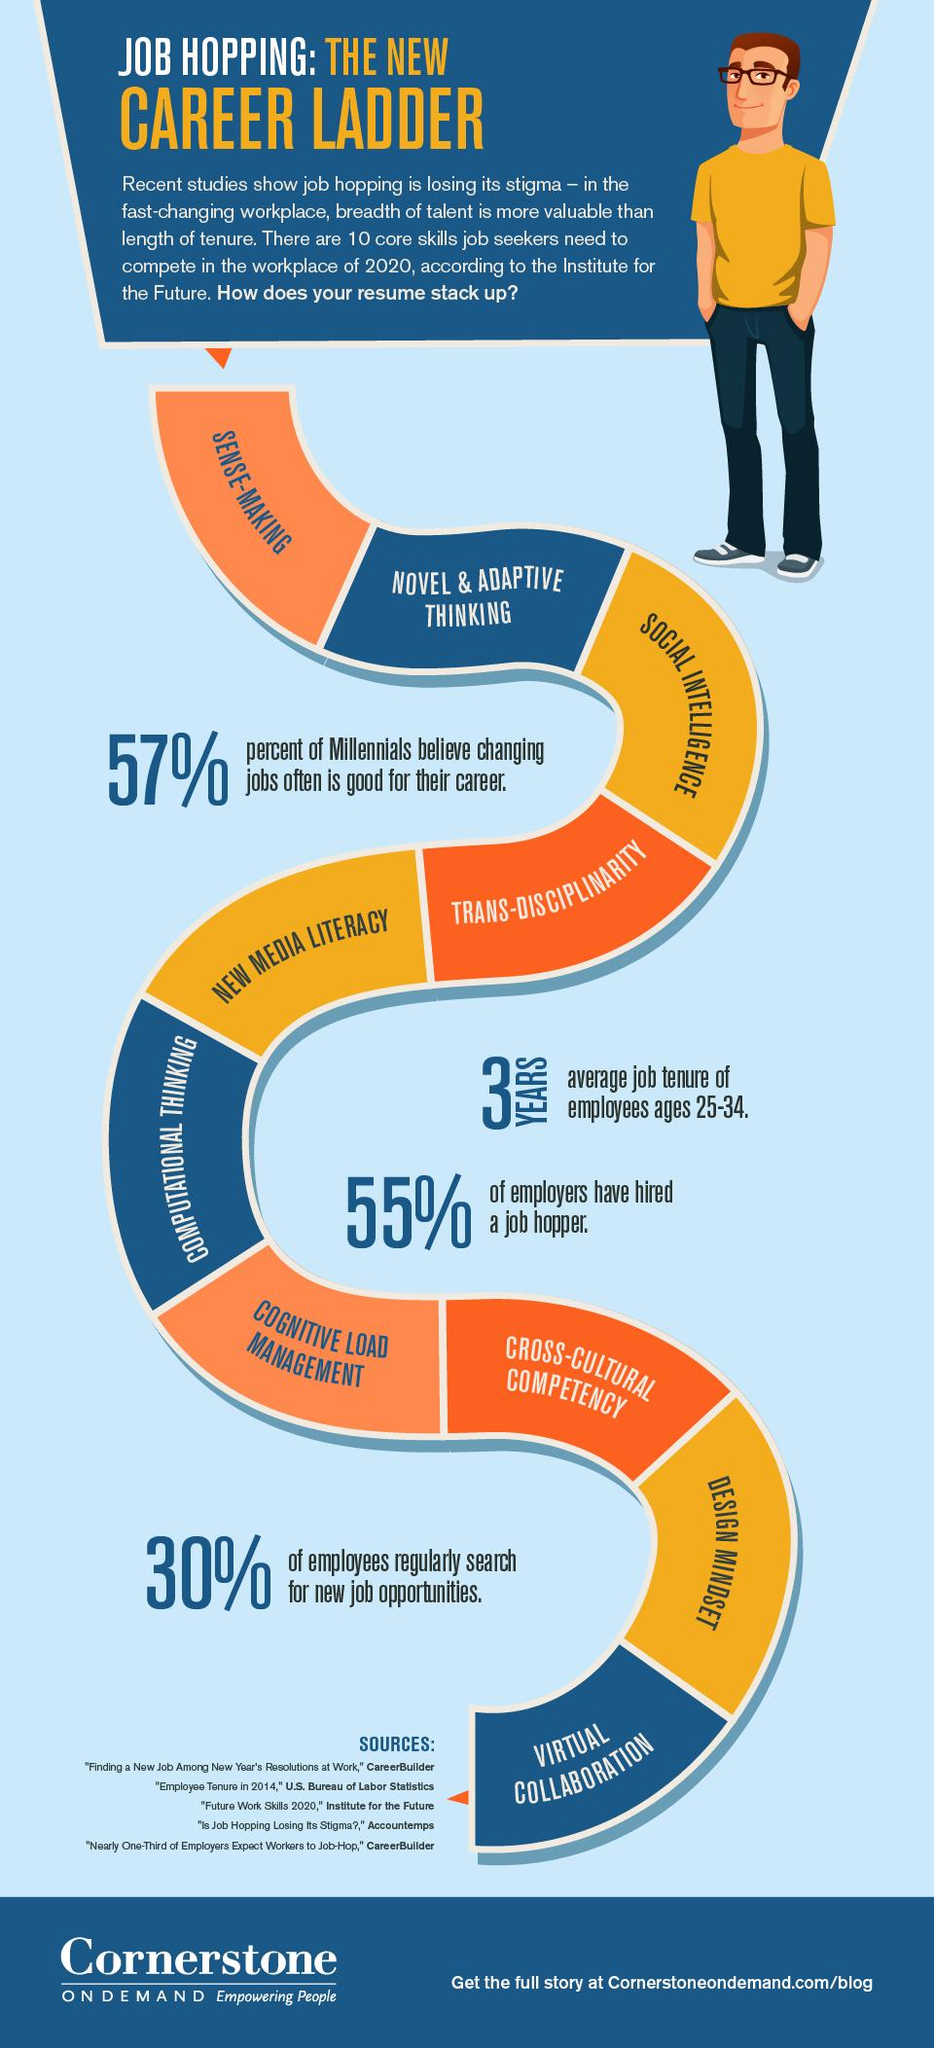Indicate a few pertinent items in this graphic. Only 30% of employees regularly search for new job openings, according to the survey. According to a recent survey, approximately 45% of employers have not hired someone with a history of job hopping. According to a survey, a significant percentage of people do not believe that changing jobs is beneficial for their career, with 43% falling into this category. 